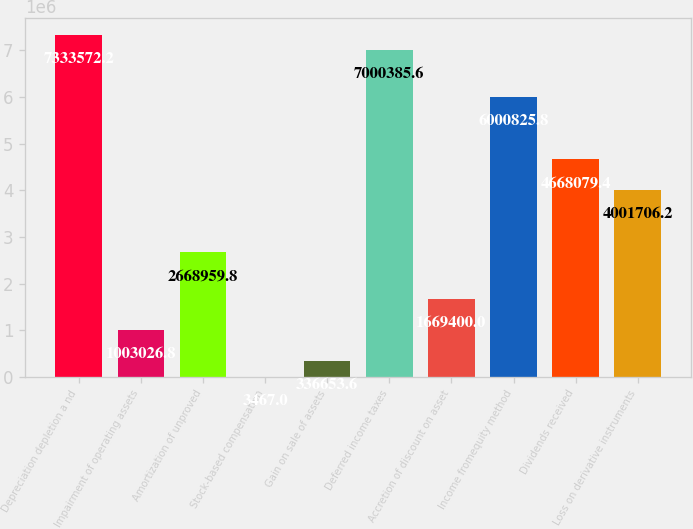Convert chart to OTSL. <chart><loc_0><loc_0><loc_500><loc_500><bar_chart><fcel>Depreciation depletion a nd<fcel>Impairment of operating assets<fcel>Amortization of unproved<fcel>Stock-based compensation<fcel>Gain on sale of assets<fcel>Deferred income taxes<fcel>Accretion of discount on asset<fcel>Income fromequity method<fcel>Dividends received<fcel>Loss on derivative instruments<nl><fcel>7.33357e+06<fcel>1.00303e+06<fcel>2.66896e+06<fcel>3467<fcel>336654<fcel>7.00039e+06<fcel>1.6694e+06<fcel>6.00083e+06<fcel>4.66808e+06<fcel>4.00171e+06<nl></chart> 